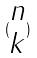<formula> <loc_0><loc_0><loc_500><loc_500>( \begin{matrix} n \\ k \end{matrix} )</formula> 